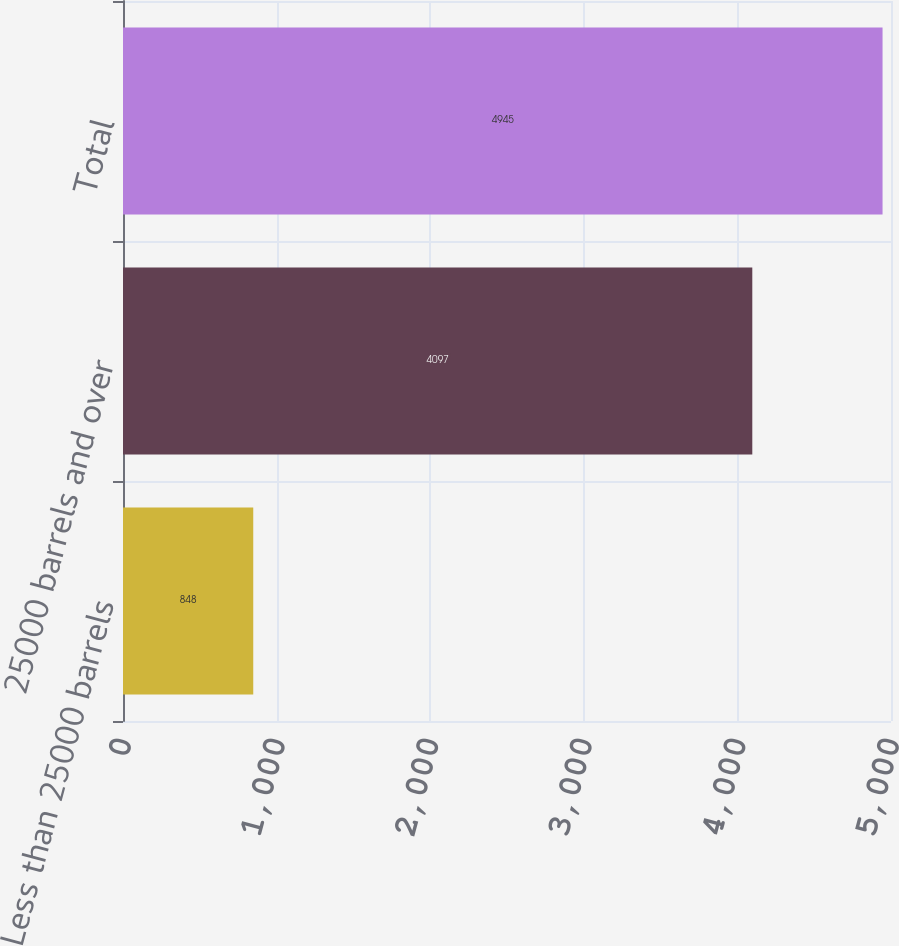Convert chart to OTSL. <chart><loc_0><loc_0><loc_500><loc_500><bar_chart><fcel>Less than 25000 barrels<fcel>25000 barrels and over<fcel>Total<nl><fcel>848<fcel>4097<fcel>4945<nl></chart> 